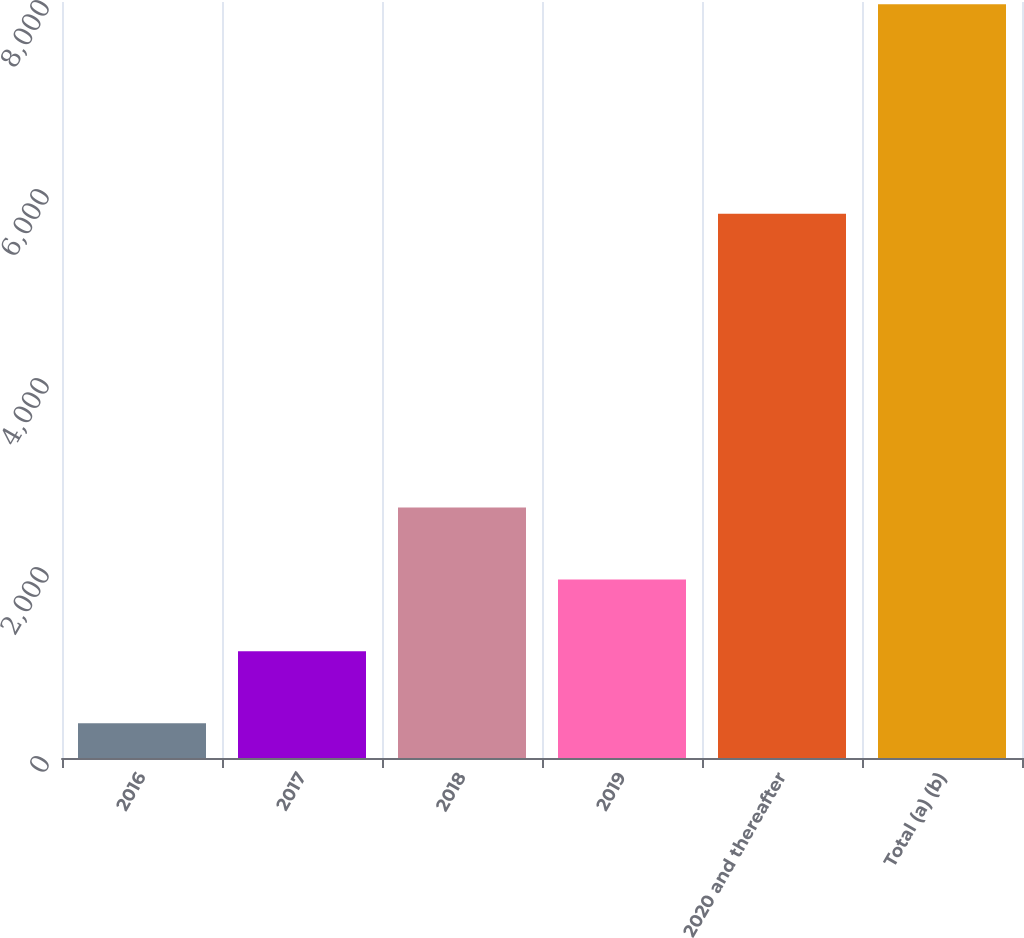Convert chart to OTSL. <chart><loc_0><loc_0><loc_500><loc_500><bar_chart><fcel>2016<fcel>2017<fcel>2018<fcel>2019<fcel>2020 and thereafter<fcel>Total (a) (b)<nl><fcel>369<fcel>1129.6<fcel>2650.8<fcel>1890.2<fcel>5758<fcel>7975<nl></chart> 